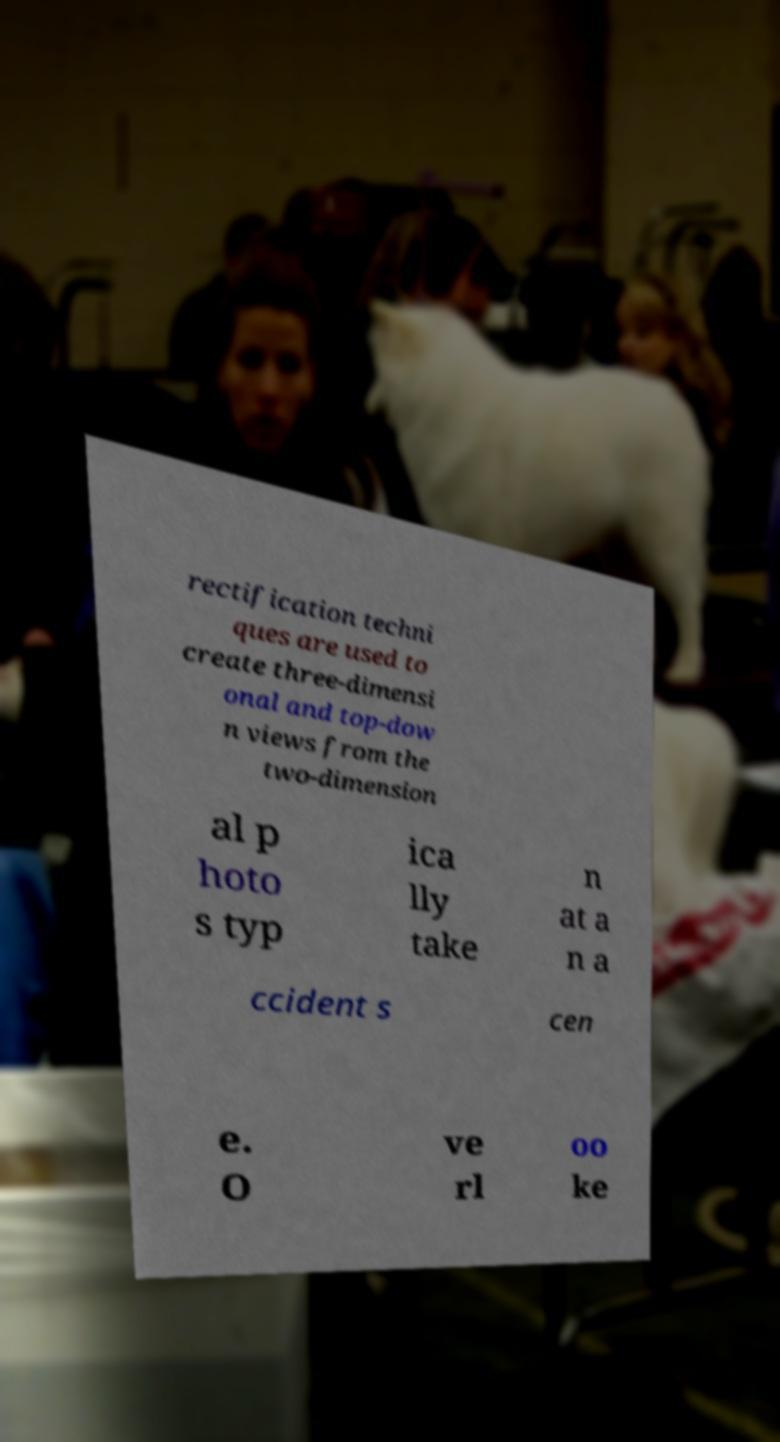Please read and relay the text visible in this image. What does it say? rectification techni ques are used to create three-dimensi onal and top-dow n views from the two-dimension al p hoto s typ ica lly take n at a n a ccident s cen e. O ve rl oo ke 